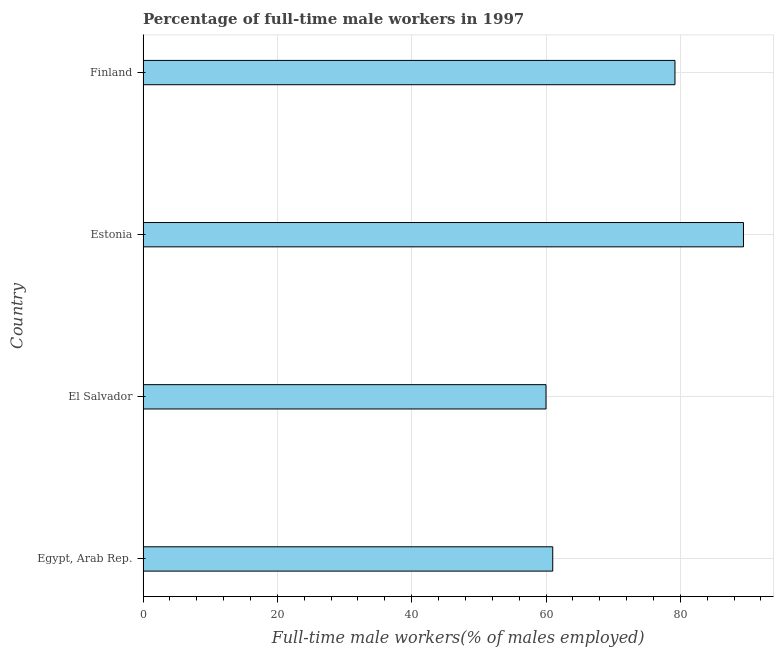Does the graph contain any zero values?
Provide a succinct answer. No. What is the title of the graph?
Make the answer very short. Percentage of full-time male workers in 1997. What is the label or title of the X-axis?
Offer a very short reply. Full-time male workers(% of males employed). What is the percentage of full-time male workers in El Salvador?
Make the answer very short. 60. Across all countries, what is the maximum percentage of full-time male workers?
Your answer should be compact. 89.4. In which country was the percentage of full-time male workers maximum?
Offer a terse response. Estonia. In which country was the percentage of full-time male workers minimum?
Ensure brevity in your answer.  El Salvador. What is the sum of the percentage of full-time male workers?
Provide a short and direct response. 289.6. What is the difference between the percentage of full-time male workers in Egypt, Arab Rep. and Estonia?
Make the answer very short. -28.4. What is the average percentage of full-time male workers per country?
Make the answer very short. 72.4. What is the median percentage of full-time male workers?
Ensure brevity in your answer.  70.1. In how many countries, is the percentage of full-time male workers greater than 72 %?
Provide a short and direct response. 2. What is the ratio of the percentage of full-time male workers in Egypt, Arab Rep. to that in Finland?
Provide a short and direct response. 0.77. What is the difference between the highest and the second highest percentage of full-time male workers?
Your answer should be very brief. 10.2. What is the difference between the highest and the lowest percentage of full-time male workers?
Your answer should be very brief. 29.4. How many bars are there?
Your answer should be very brief. 4. Are all the bars in the graph horizontal?
Provide a short and direct response. Yes. What is the difference between two consecutive major ticks on the X-axis?
Provide a succinct answer. 20. What is the Full-time male workers(% of males employed) of Estonia?
Ensure brevity in your answer.  89.4. What is the Full-time male workers(% of males employed) in Finland?
Provide a short and direct response. 79.2. What is the difference between the Full-time male workers(% of males employed) in Egypt, Arab Rep. and Estonia?
Your answer should be compact. -28.4. What is the difference between the Full-time male workers(% of males employed) in Egypt, Arab Rep. and Finland?
Provide a short and direct response. -18.2. What is the difference between the Full-time male workers(% of males employed) in El Salvador and Estonia?
Provide a short and direct response. -29.4. What is the difference between the Full-time male workers(% of males employed) in El Salvador and Finland?
Offer a very short reply. -19.2. What is the difference between the Full-time male workers(% of males employed) in Estonia and Finland?
Give a very brief answer. 10.2. What is the ratio of the Full-time male workers(% of males employed) in Egypt, Arab Rep. to that in Estonia?
Your answer should be compact. 0.68. What is the ratio of the Full-time male workers(% of males employed) in Egypt, Arab Rep. to that in Finland?
Make the answer very short. 0.77. What is the ratio of the Full-time male workers(% of males employed) in El Salvador to that in Estonia?
Your response must be concise. 0.67. What is the ratio of the Full-time male workers(% of males employed) in El Salvador to that in Finland?
Your response must be concise. 0.76. What is the ratio of the Full-time male workers(% of males employed) in Estonia to that in Finland?
Provide a short and direct response. 1.13. 